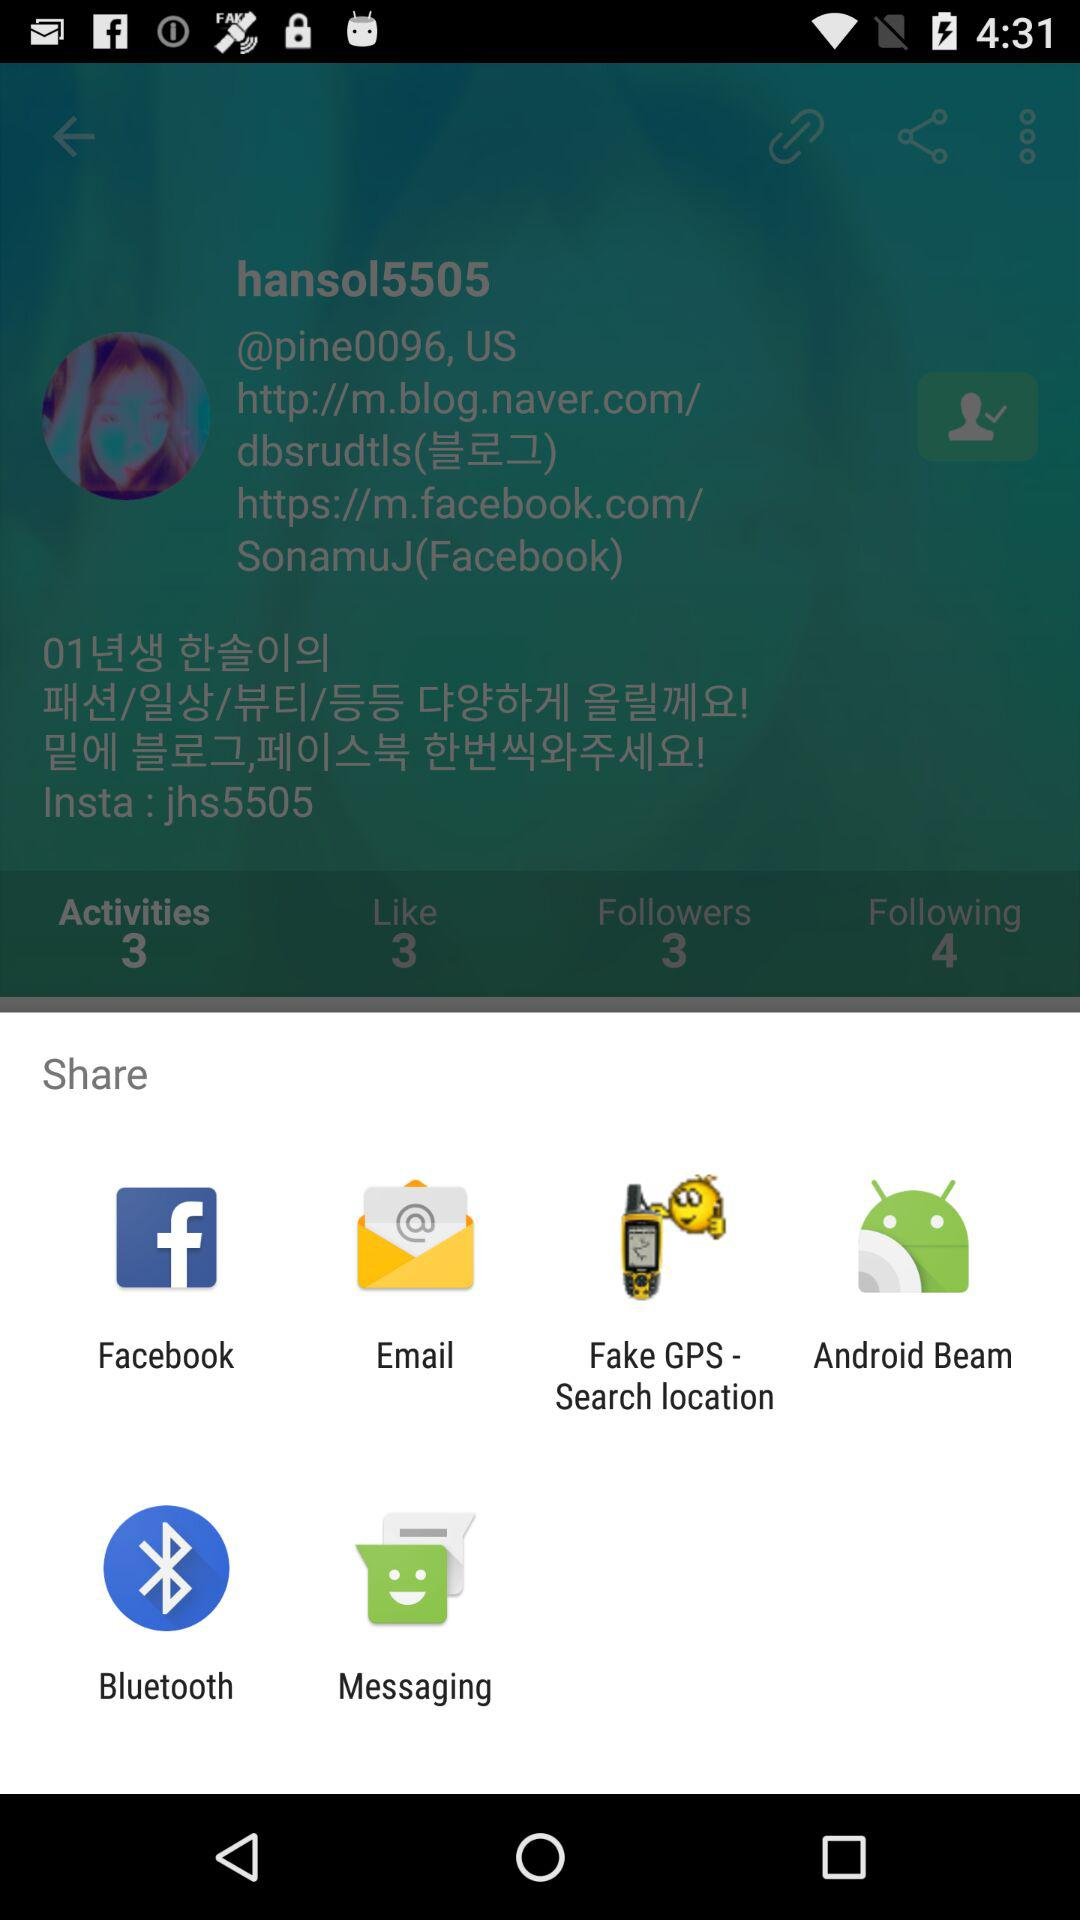What is the username? The username is "hansol5505". 